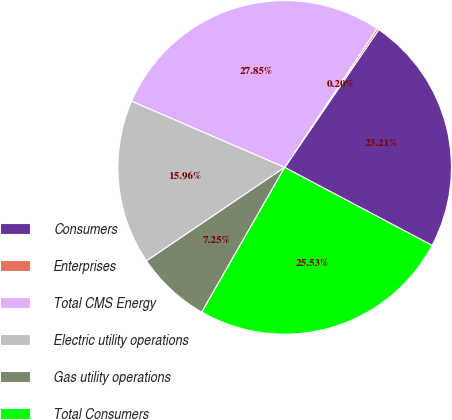Convert chart to OTSL. <chart><loc_0><loc_0><loc_500><loc_500><pie_chart><fcel>Consumers<fcel>Enterprises<fcel>Total CMS Energy<fcel>Electric utility operations<fcel>Gas utility operations<fcel>Total Consumers<nl><fcel>23.21%<fcel>0.2%<fcel>27.85%<fcel>15.96%<fcel>7.25%<fcel>25.53%<nl></chart> 